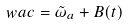Convert formula to latex. <formula><loc_0><loc_0><loc_500><loc_500>\ w a c = \tilde { \omega } _ { a } + B ( t )</formula> 